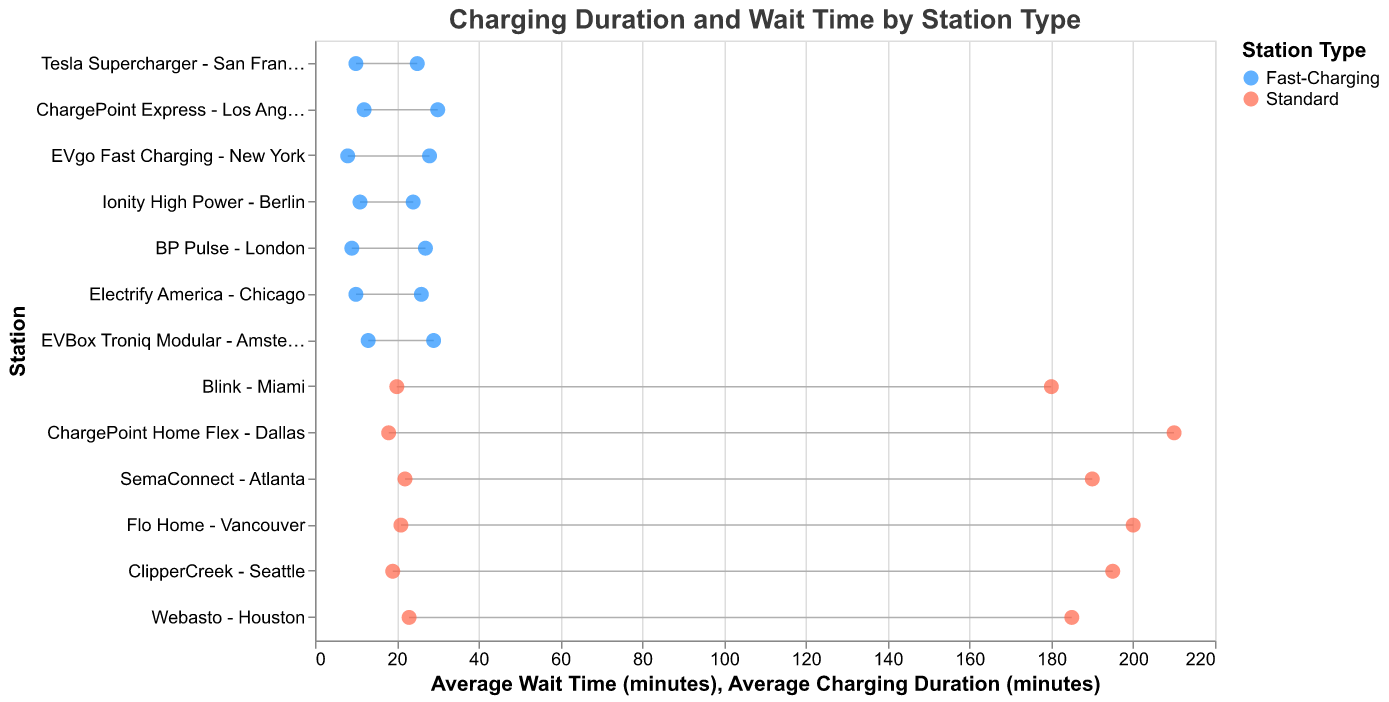What is the title of the chart? The title of the chart is located at the top and it explains the main subject of the figure, specifically the relationship between the charging duration and wait time by station type.
Answer: Charging Duration and Wait Time by Station Type How many stations are categorized as Fast-Charging? By looking at the color coding and the station type labels, count the number of stations marked as Fast-Charging.
Answer: 7 Which station has the highest average charging duration? Identify the station with the highest value on the axis representing average charging duration. The station with the longest horizontal line segment ending at the farthest right point on the chart is the one with the highest average charging duration.
Answer: ChargePoint Home Flex - Dallas What is the difference in average charging duration between the fastest Fast-Charging station and the slowest Standard station? Identify the station with the shortest average charging duration among the Fast-Charging stations and the one with the longest average charging duration among the Standard stations. Subtract the average charging duration of the fastest Fast-Charging station (Ionity High Power - Berlin) from that of the slowest Standard station (ChargePoint Home Flex - Dallas).
Answer: 210 - 24 = 186 minutes Which station has the longest average wait time? Identify the station with the highest value on the axis representing average wait time. The station with the longest horizontal line segment starting from the farthest left point on the chart is the one with the longest average wait time.
Answer: Webasto - Houston Compare the average wait times of the stations with the shortest and the longest average charging durations. Find the wait time corresponding to the station with the shortest charging duration (Ionity High Power - Berlin) and the wait time for the station with the longest charging duration (ChargePoint Home Flex - Dallas).
Answer: Ionity High Power - Berlin has 11 minutes and ChargePoint Home Flex - Dallas has 18 minutes Which station has the smallest difference between average charging duration and average wait time? For each station, calculate the difference between the average charging duration and the average wait time. Identify the station with the smallest difference.
Answer: Tesla Supercharger - San Francisco (25 - 10 = 15 minutes) On average, do Fast-Charging stations have shorter wait times than Standard stations? Calculate the average wait time for Fast-Charging stations and the average wait time for Standard stations. Compare the two averages to determine if one is generally shorter than the other.
Answer: Yes, Fast-Charging stations have shorter wait times Which station has the closest proximity between its average charging duration and average wait time? This is determined by the station whose dumbbell line segments are shortest, meaning its average charging duration and wait time values are most similar.
Answer: EVgo Fast Charging - New York 